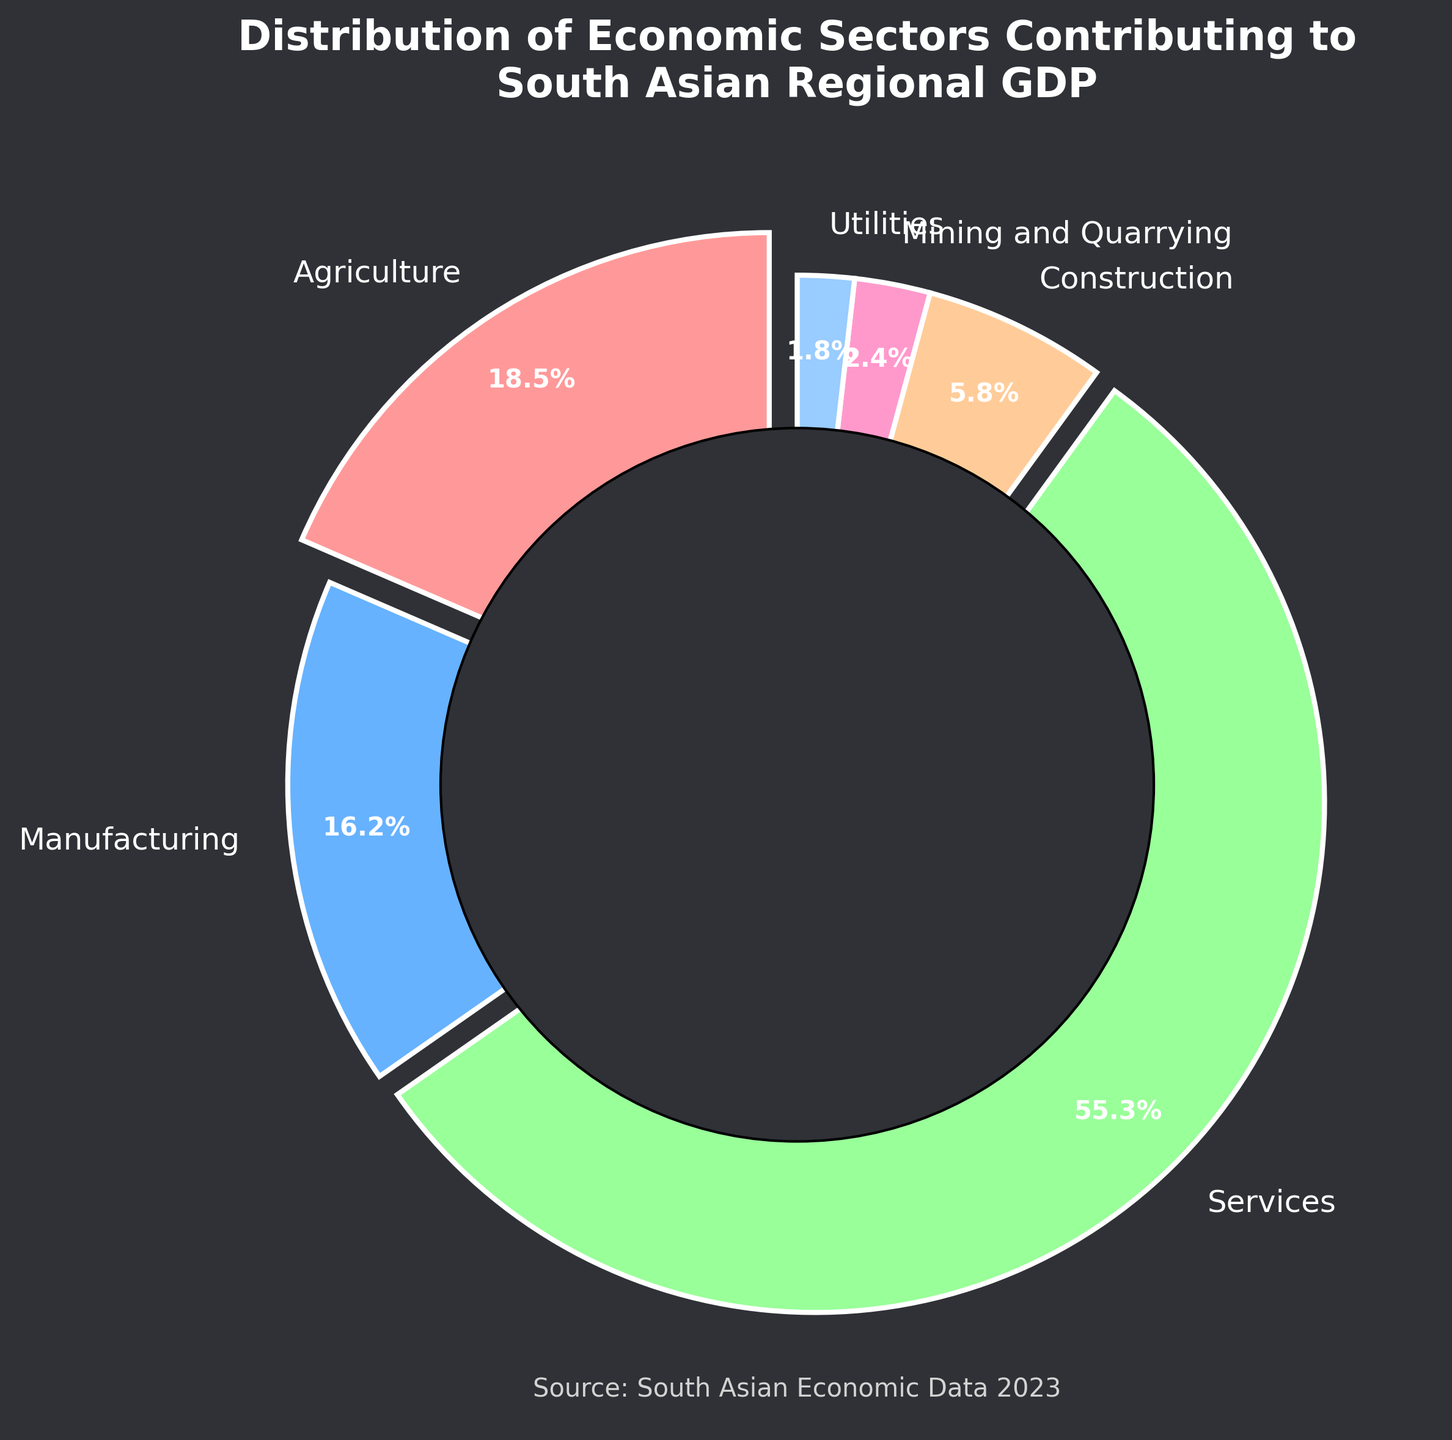Which sector contributes the most to the South Asian regional GDP? By observing the size of the pie sections, the 'Services' sector represents the largest portion. The percentage for Services is 55.3%, which is the highest among all sectors.
Answer: Services What is the combined contribution of Agriculture and Manufacturing sectors? To find the combined contribution, sum the percentages of Agriculture (18.5%) and Manufacturing (16.2%). The calculation is 18.5 + 16.2 = 34.7%.
Answer: 34.7% How does the contribution of Construction compare to that of Mining and Quarrying? By comparing the two sectors, Construction has a percentage of 5.8%, while Mining and Quarrying has 2.4%. So, Construction contributes more than Mining and Quarrying.
Answer: Construction contributes more What sector contributes the least to the South Asian regional GDP? Checking the percentages, Utilities has the smallest percentage contribution at 1.8%.
Answer: Utilities What is the difference between the contributions of the Services and Agriculture sectors? Subtract the percentage of Agriculture from that of Services: 55.3 - 18.5 = 36.8%.
Answer: 36.8% Which sectors combined contribute more than 50% to the regional GDP? Adding the percentages of Services (55.3%), we can see that it alone contributes more than 50%.
Answer: Services Among the sectors listed, which two sectors have the smallest contributions and what is their combined effect? The smallest contributions are from Utilities (1.8%) and Mining and Quarrying (2.4%). Their combined contribution is 1.8 + 2.4 = 4.2%.
Answer: 4.2% How does the contribution of Manufacturing compare to the combined contribution of Mining and Quarrying plus Utilities? Manufacturing contributes 16.2%, and the combined contribution of Mining and Quarrying plus Utilities is 2.4 + 1.8 = 4.2%. Manufacturing contributes more.
Answer: Manufacturing contributes more What is the difference between the combined contribution of Agriculture and Construction and that of the Services sector? First, find the combined contribution of Agriculture and Construction: 18.5 + 5.8 = 24.3%. Then, find the difference from Services: 55.3 - 24.3 = 31%.
Answer: 31% How many sectors contribute less than 10% each to the South Asian regional GDP? By observing the percentages, the sectors that contribute less than 10% are Construction (5.8%), Mining and Quarrying (2.4%), and Utilities (1.8%), totaling three sectors.
Answer: Three sectors 